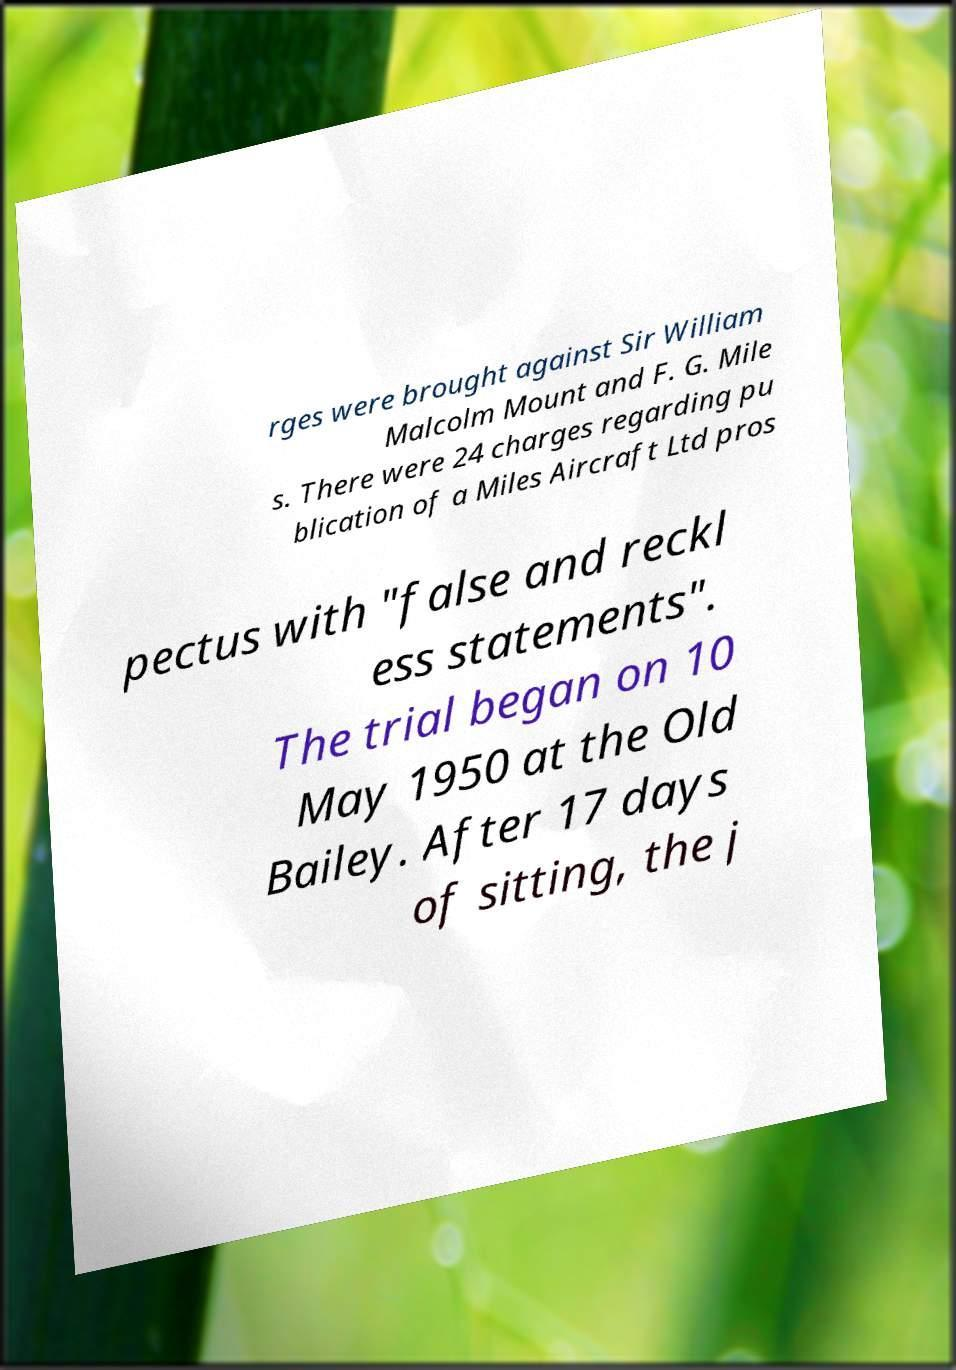There's text embedded in this image that I need extracted. Can you transcribe it verbatim? rges were brought against Sir William Malcolm Mount and F. G. Mile s. There were 24 charges regarding pu blication of a Miles Aircraft Ltd pros pectus with "false and reckl ess statements". The trial began on 10 May 1950 at the Old Bailey. After 17 days of sitting, the j 